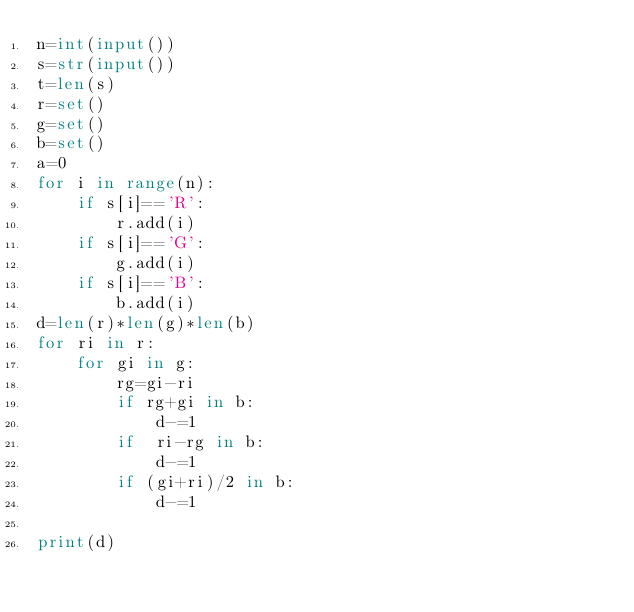<code> <loc_0><loc_0><loc_500><loc_500><_Python_>n=int(input())
s=str(input())
t=len(s)
r=set()
g=set()
b=set()
a=0
for i in range(n):
    if s[i]=='R':
        r.add(i)
    if s[i]=='G':
        g.add(i)
    if s[i]=='B':
        b.add(i)
d=len(r)*len(g)*len(b)
for ri in r:
    for gi in g:
        rg=gi-ri
        if rg+gi in b:
            d-=1
        if  ri-rg in b:
            d-=1
        if (gi+ri)/2 in b:
            d-=1

print(d)</code> 